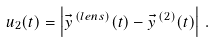Convert formula to latex. <formula><loc_0><loc_0><loc_500><loc_500>u _ { 2 } ( t ) = \left | { \vec { y } } ^ { \, ( l e n s ) } ( t ) - { \vec { y } } ^ { \, ( 2 ) } ( t ) \right | \, .</formula> 